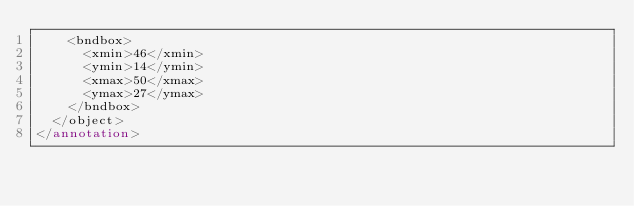Convert code to text. <code><loc_0><loc_0><loc_500><loc_500><_XML_>    <bndbox>
      <xmin>46</xmin>
      <ymin>14</ymin>
      <xmax>50</xmax>
      <ymax>27</ymax>
    </bndbox>
  </object>
</annotation>
</code> 